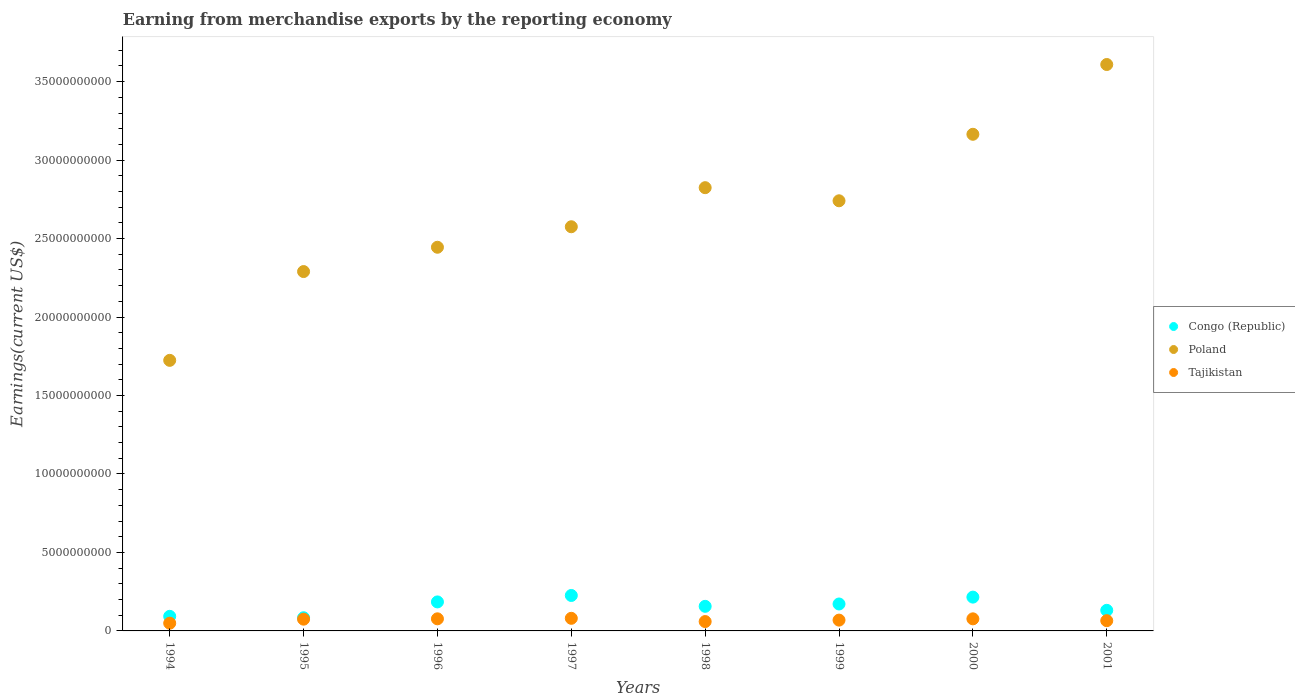Is the number of dotlines equal to the number of legend labels?
Your response must be concise. Yes. What is the amount earned from merchandise exports in Congo (Republic) in 1999?
Provide a short and direct response. 1.72e+09. Across all years, what is the maximum amount earned from merchandise exports in Congo (Republic)?
Offer a very short reply. 2.26e+09. Across all years, what is the minimum amount earned from merchandise exports in Tajikistan?
Give a very brief answer. 4.92e+08. In which year was the amount earned from merchandise exports in Tajikistan maximum?
Ensure brevity in your answer.  1997. What is the total amount earned from merchandise exports in Tajikistan in the graph?
Give a very brief answer. 5.52e+09. What is the difference between the amount earned from merchandise exports in Congo (Republic) in 1994 and that in 1998?
Your answer should be very brief. -6.38e+08. What is the difference between the amount earned from merchandise exports in Tajikistan in 1998 and the amount earned from merchandise exports in Congo (Republic) in 1999?
Offer a terse response. -1.12e+09. What is the average amount earned from merchandise exports in Poland per year?
Ensure brevity in your answer.  2.67e+1. In the year 1999, what is the difference between the amount earned from merchandise exports in Poland and amount earned from merchandise exports in Tajikistan?
Make the answer very short. 2.67e+1. What is the ratio of the amount earned from merchandise exports in Congo (Republic) in 1996 to that in 2000?
Ensure brevity in your answer.  0.86. Is the amount earned from merchandise exports in Tajikistan in 1996 less than that in 2001?
Ensure brevity in your answer.  No. What is the difference between the highest and the second highest amount earned from merchandise exports in Congo (Republic)?
Provide a short and direct response. 1.05e+08. What is the difference between the highest and the lowest amount earned from merchandise exports in Poland?
Give a very brief answer. 1.89e+1. In how many years, is the amount earned from merchandise exports in Poland greater than the average amount earned from merchandise exports in Poland taken over all years?
Your response must be concise. 4. Is the amount earned from merchandise exports in Poland strictly greater than the amount earned from merchandise exports in Congo (Republic) over the years?
Your response must be concise. Yes. How many years are there in the graph?
Offer a terse response. 8. Are the values on the major ticks of Y-axis written in scientific E-notation?
Make the answer very short. No. Does the graph contain any zero values?
Provide a succinct answer. No. Does the graph contain grids?
Give a very brief answer. No. How many legend labels are there?
Your answer should be compact. 3. How are the legend labels stacked?
Give a very brief answer. Vertical. What is the title of the graph?
Your answer should be compact. Earning from merchandise exports by the reporting economy. What is the label or title of the Y-axis?
Your answer should be compact. Earnings(current US$). What is the Earnings(current US$) of Congo (Republic) in 1994?
Ensure brevity in your answer.  9.29e+08. What is the Earnings(current US$) of Poland in 1994?
Your answer should be compact. 1.72e+1. What is the Earnings(current US$) in Tajikistan in 1994?
Give a very brief answer. 4.92e+08. What is the Earnings(current US$) of Congo (Republic) in 1995?
Your answer should be compact. 8.39e+08. What is the Earnings(current US$) of Poland in 1995?
Provide a succinct answer. 2.29e+1. What is the Earnings(current US$) in Tajikistan in 1995?
Provide a short and direct response. 7.49e+08. What is the Earnings(current US$) of Congo (Republic) in 1996?
Ensure brevity in your answer.  1.85e+09. What is the Earnings(current US$) of Poland in 1996?
Ensure brevity in your answer.  2.44e+1. What is the Earnings(current US$) in Tajikistan in 1996?
Your answer should be compact. 7.72e+08. What is the Earnings(current US$) of Congo (Republic) in 1997?
Your answer should be compact. 2.26e+09. What is the Earnings(current US$) in Poland in 1997?
Offer a very short reply. 2.58e+1. What is the Earnings(current US$) in Tajikistan in 1997?
Keep it short and to the point. 8.03e+08. What is the Earnings(current US$) in Congo (Republic) in 1998?
Give a very brief answer. 1.57e+09. What is the Earnings(current US$) in Poland in 1998?
Provide a succinct answer. 2.82e+1. What is the Earnings(current US$) of Tajikistan in 1998?
Provide a short and direct response. 5.97e+08. What is the Earnings(current US$) in Congo (Republic) in 1999?
Provide a short and direct response. 1.72e+09. What is the Earnings(current US$) in Poland in 1999?
Offer a terse response. 2.74e+1. What is the Earnings(current US$) of Tajikistan in 1999?
Offer a terse response. 6.89e+08. What is the Earnings(current US$) in Congo (Republic) in 2000?
Ensure brevity in your answer.  2.15e+09. What is the Earnings(current US$) in Poland in 2000?
Ensure brevity in your answer.  3.16e+1. What is the Earnings(current US$) of Tajikistan in 2000?
Your response must be concise. 7.70e+08. What is the Earnings(current US$) of Congo (Republic) in 2001?
Keep it short and to the point. 1.31e+09. What is the Earnings(current US$) in Poland in 2001?
Provide a succinct answer. 3.61e+1. What is the Earnings(current US$) of Tajikistan in 2001?
Ensure brevity in your answer.  6.53e+08. Across all years, what is the maximum Earnings(current US$) of Congo (Republic)?
Ensure brevity in your answer.  2.26e+09. Across all years, what is the maximum Earnings(current US$) in Poland?
Your response must be concise. 3.61e+1. Across all years, what is the maximum Earnings(current US$) of Tajikistan?
Provide a succinct answer. 8.03e+08. Across all years, what is the minimum Earnings(current US$) of Congo (Republic)?
Offer a very short reply. 8.39e+08. Across all years, what is the minimum Earnings(current US$) in Poland?
Your answer should be compact. 1.72e+1. Across all years, what is the minimum Earnings(current US$) of Tajikistan?
Your answer should be compact. 4.92e+08. What is the total Earnings(current US$) of Congo (Republic) in the graph?
Offer a very short reply. 1.26e+1. What is the total Earnings(current US$) of Poland in the graph?
Your response must be concise. 2.14e+11. What is the total Earnings(current US$) of Tajikistan in the graph?
Provide a short and direct response. 5.52e+09. What is the difference between the Earnings(current US$) of Congo (Republic) in 1994 and that in 1995?
Make the answer very short. 9.07e+07. What is the difference between the Earnings(current US$) of Poland in 1994 and that in 1995?
Offer a terse response. -5.66e+09. What is the difference between the Earnings(current US$) in Tajikistan in 1994 and that in 1995?
Your answer should be very brief. -2.57e+08. What is the difference between the Earnings(current US$) in Congo (Republic) in 1994 and that in 1996?
Give a very brief answer. -9.19e+08. What is the difference between the Earnings(current US$) of Poland in 1994 and that in 1996?
Provide a succinct answer. -7.21e+09. What is the difference between the Earnings(current US$) in Tajikistan in 1994 and that in 1996?
Your answer should be compact. -2.80e+08. What is the difference between the Earnings(current US$) of Congo (Republic) in 1994 and that in 1997?
Your answer should be very brief. -1.33e+09. What is the difference between the Earnings(current US$) in Poland in 1994 and that in 1997?
Your answer should be compact. -8.51e+09. What is the difference between the Earnings(current US$) of Tajikistan in 1994 and that in 1997?
Keep it short and to the point. -3.11e+08. What is the difference between the Earnings(current US$) in Congo (Republic) in 1994 and that in 1998?
Keep it short and to the point. -6.38e+08. What is the difference between the Earnings(current US$) of Poland in 1994 and that in 1998?
Give a very brief answer. -1.10e+1. What is the difference between the Earnings(current US$) of Tajikistan in 1994 and that in 1998?
Your response must be concise. -1.05e+08. What is the difference between the Earnings(current US$) in Congo (Republic) in 1994 and that in 1999?
Provide a succinct answer. -7.87e+08. What is the difference between the Earnings(current US$) in Poland in 1994 and that in 1999?
Ensure brevity in your answer.  -1.02e+1. What is the difference between the Earnings(current US$) in Tajikistan in 1994 and that in 1999?
Keep it short and to the point. -1.97e+08. What is the difference between the Earnings(current US$) in Congo (Republic) in 1994 and that in 2000?
Provide a short and direct response. -1.22e+09. What is the difference between the Earnings(current US$) in Poland in 1994 and that in 2000?
Offer a very short reply. -1.44e+1. What is the difference between the Earnings(current US$) in Tajikistan in 1994 and that in 2000?
Your answer should be very brief. -2.78e+08. What is the difference between the Earnings(current US$) in Congo (Republic) in 1994 and that in 2001?
Provide a short and direct response. -3.83e+08. What is the difference between the Earnings(current US$) in Poland in 1994 and that in 2001?
Provide a succinct answer. -1.89e+1. What is the difference between the Earnings(current US$) of Tajikistan in 1994 and that in 2001?
Make the answer very short. -1.61e+08. What is the difference between the Earnings(current US$) in Congo (Republic) in 1995 and that in 1996?
Ensure brevity in your answer.  -1.01e+09. What is the difference between the Earnings(current US$) of Poland in 1995 and that in 1996?
Keep it short and to the point. -1.55e+09. What is the difference between the Earnings(current US$) of Tajikistan in 1995 and that in 1996?
Keep it short and to the point. -2.29e+07. What is the difference between the Earnings(current US$) of Congo (Republic) in 1995 and that in 1997?
Keep it short and to the point. -1.42e+09. What is the difference between the Earnings(current US$) of Poland in 1995 and that in 1997?
Offer a very short reply. -2.86e+09. What is the difference between the Earnings(current US$) in Tajikistan in 1995 and that in 1997?
Give a very brief answer. -5.48e+07. What is the difference between the Earnings(current US$) of Congo (Republic) in 1995 and that in 1998?
Ensure brevity in your answer.  -7.28e+08. What is the difference between the Earnings(current US$) of Poland in 1995 and that in 1998?
Ensure brevity in your answer.  -5.35e+09. What is the difference between the Earnings(current US$) of Tajikistan in 1995 and that in 1998?
Make the answer very short. 1.52e+08. What is the difference between the Earnings(current US$) of Congo (Republic) in 1995 and that in 1999?
Ensure brevity in your answer.  -8.78e+08. What is the difference between the Earnings(current US$) of Poland in 1995 and that in 1999?
Provide a succinct answer. -4.51e+09. What is the difference between the Earnings(current US$) of Tajikistan in 1995 and that in 1999?
Give a very brief answer. 5.99e+07. What is the difference between the Earnings(current US$) in Congo (Republic) in 1995 and that in 2000?
Make the answer very short. -1.32e+09. What is the difference between the Earnings(current US$) of Poland in 1995 and that in 2000?
Your answer should be very brief. -8.75e+09. What is the difference between the Earnings(current US$) in Tajikistan in 1995 and that in 2000?
Ensure brevity in your answer.  -2.14e+07. What is the difference between the Earnings(current US$) in Congo (Republic) in 1995 and that in 2001?
Ensure brevity in your answer.  -4.73e+08. What is the difference between the Earnings(current US$) of Poland in 1995 and that in 2001?
Your response must be concise. -1.32e+1. What is the difference between the Earnings(current US$) of Tajikistan in 1995 and that in 2001?
Ensure brevity in your answer.  9.57e+07. What is the difference between the Earnings(current US$) in Congo (Republic) in 1996 and that in 1997?
Make the answer very short. -4.11e+08. What is the difference between the Earnings(current US$) of Poland in 1996 and that in 1997?
Keep it short and to the point. -1.31e+09. What is the difference between the Earnings(current US$) in Tajikistan in 1996 and that in 1997?
Give a very brief answer. -3.18e+07. What is the difference between the Earnings(current US$) of Congo (Republic) in 1996 and that in 1998?
Give a very brief answer. 2.81e+08. What is the difference between the Earnings(current US$) of Poland in 1996 and that in 1998?
Make the answer very short. -3.80e+09. What is the difference between the Earnings(current US$) in Tajikistan in 1996 and that in 1998?
Make the answer very short. 1.75e+08. What is the difference between the Earnings(current US$) in Congo (Republic) in 1996 and that in 1999?
Your answer should be compact. 1.32e+08. What is the difference between the Earnings(current US$) in Poland in 1996 and that in 1999?
Provide a short and direct response. -2.96e+09. What is the difference between the Earnings(current US$) in Tajikistan in 1996 and that in 1999?
Your answer should be compact. 8.29e+07. What is the difference between the Earnings(current US$) of Congo (Republic) in 1996 and that in 2000?
Your response must be concise. -3.06e+08. What is the difference between the Earnings(current US$) of Poland in 1996 and that in 2000?
Make the answer very short. -7.20e+09. What is the difference between the Earnings(current US$) in Tajikistan in 1996 and that in 2000?
Provide a short and direct response. 1.53e+06. What is the difference between the Earnings(current US$) of Congo (Republic) in 1996 and that in 2001?
Offer a very short reply. 5.36e+08. What is the difference between the Earnings(current US$) in Poland in 1996 and that in 2001?
Provide a short and direct response. -1.16e+1. What is the difference between the Earnings(current US$) in Tajikistan in 1996 and that in 2001?
Your answer should be very brief. 1.19e+08. What is the difference between the Earnings(current US$) in Congo (Republic) in 1997 and that in 1998?
Provide a succinct answer. 6.92e+08. What is the difference between the Earnings(current US$) in Poland in 1997 and that in 1998?
Make the answer very short. -2.49e+09. What is the difference between the Earnings(current US$) in Tajikistan in 1997 and that in 1998?
Keep it short and to the point. 2.07e+08. What is the difference between the Earnings(current US$) of Congo (Republic) in 1997 and that in 1999?
Make the answer very short. 5.42e+08. What is the difference between the Earnings(current US$) of Poland in 1997 and that in 1999?
Offer a very short reply. -1.65e+09. What is the difference between the Earnings(current US$) of Tajikistan in 1997 and that in 1999?
Provide a short and direct response. 1.15e+08. What is the difference between the Earnings(current US$) in Congo (Republic) in 1997 and that in 2000?
Provide a succinct answer. 1.05e+08. What is the difference between the Earnings(current US$) in Poland in 1997 and that in 2000?
Ensure brevity in your answer.  -5.89e+09. What is the difference between the Earnings(current US$) of Tajikistan in 1997 and that in 2000?
Offer a very short reply. 3.34e+07. What is the difference between the Earnings(current US$) of Congo (Republic) in 1997 and that in 2001?
Offer a terse response. 9.47e+08. What is the difference between the Earnings(current US$) in Poland in 1997 and that in 2001?
Provide a short and direct response. -1.03e+1. What is the difference between the Earnings(current US$) in Tajikistan in 1997 and that in 2001?
Provide a succinct answer. 1.50e+08. What is the difference between the Earnings(current US$) in Congo (Republic) in 1998 and that in 1999?
Provide a short and direct response. -1.49e+08. What is the difference between the Earnings(current US$) of Poland in 1998 and that in 1999?
Make the answer very short. 8.36e+08. What is the difference between the Earnings(current US$) of Tajikistan in 1998 and that in 1999?
Offer a terse response. -9.21e+07. What is the difference between the Earnings(current US$) in Congo (Republic) in 1998 and that in 2000?
Ensure brevity in your answer.  -5.87e+08. What is the difference between the Earnings(current US$) of Poland in 1998 and that in 2000?
Keep it short and to the point. -3.40e+09. What is the difference between the Earnings(current US$) in Tajikistan in 1998 and that in 2000?
Your response must be concise. -1.73e+08. What is the difference between the Earnings(current US$) of Congo (Republic) in 1998 and that in 2001?
Your answer should be very brief. 2.55e+08. What is the difference between the Earnings(current US$) of Poland in 1998 and that in 2001?
Keep it short and to the point. -7.85e+09. What is the difference between the Earnings(current US$) of Tajikistan in 1998 and that in 2001?
Make the answer very short. -5.63e+07. What is the difference between the Earnings(current US$) of Congo (Republic) in 1999 and that in 2000?
Your response must be concise. -4.38e+08. What is the difference between the Earnings(current US$) in Poland in 1999 and that in 2000?
Your answer should be very brief. -4.24e+09. What is the difference between the Earnings(current US$) of Tajikistan in 1999 and that in 2000?
Make the answer very short. -8.13e+07. What is the difference between the Earnings(current US$) of Congo (Republic) in 1999 and that in 2001?
Provide a short and direct response. 4.04e+08. What is the difference between the Earnings(current US$) of Poland in 1999 and that in 2001?
Offer a very short reply. -8.68e+09. What is the difference between the Earnings(current US$) in Tajikistan in 1999 and that in 2001?
Ensure brevity in your answer.  3.58e+07. What is the difference between the Earnings(current US$) in Congo (Republic) in 2000 and that in 2001?
Offer a very short reply. 8.42e+08. What is the difference between the Earnings(current US$) in Poland in 2000 and that in 2001?
Give a very brief answer. -4.45e+09. What is the difference between the Earnings(current US$) in Tajikistan in 2000 and that in 2001?
Offer a terse response. 1.17e+08. What is the difference between the Earnings(current US$) in Congo (Republic) in 1994 and the Earnings(current US$) in Poland in 1995?
Your answer should be very brief. -2.20e+1. What is the difference between the Earnings(current US$) of Congo (Republic) in 1994 and the Earnings(current US$) of Tajikistan in 1995?
Give a very brief answer. 1.81e+08. What is the difference between the Earnings(current US$) of Poland in 1994 and the Earnings(current US$) of Tajikistan in 1995?
Provide a short and direct response. 1.65e+1. What is the difference between the Earnings(current US$) in Congo (Republic) in 1994 and the Earnings(current US$) in Poland in 1996?
Your answer should be compact. -2.35e+1. What is the difference between the Earnings(current US$) of Congo (Republic) in 1994 and the Earnings(current US$) of Tajikistan in 1996?
Your response must be concise. 1.58e+08. What is the difference between the Earnings(current US$) of Poland in 1994 and the Earnings(current US$) of Tajikistan in 1996?
Provide a succinct answer. 1.65e+1. What is the difference between the Earnings(current US$) in Congo (Republic) in 1994 and the Earnings(current US$) in Poland in 1997?
Ensure brevity in your answer.  -2.48e+1. What is the difference between the Earnings(current US$) of Congo (Republic) in 1994 and the Earnings(current US$) of Tajikistan in 1997?
Ensure brevity in your answer.  1.26e+08. What is the difference between the Earnings(current US$) of Poland in 1994 and the Earnings(current US$) of Tajikistan in 1997?
Offer a very short reply. 1.64e+1. What is the difference between the Earnings(current US$) of Congo (Republic) in 1994 and the Earnings(current US$) of Poland in 1998?
Your response must be concise. -2.73e+1. What is the difference between the Earnings(current US$) of Congo (Republic) in 1994 and the Earnings(current US$) of Tajikistan in 1998?
Provide a succinct answer. 3.33e+08. What is the difference between the Earnings(current US$) of Poland in 1994 and the Earnings(current US$) of Tajikistan in 1998?
Make the answer very short. 1.66e+1. What is the difference between the Earnings(current US$) of Congo (Republic) in 1994 and the Earnings(current US$) of Poland in 1999?
Ensure brevity in your answer.  -2.65e+1. What is the difference between the Earnings(current US$) in Congo (Republic) in 1994 and the Earnings(current US$) in Tajikistan in 1999?
Your answer should be compact. 2.41e+08. What is the difference between the Earnings(current US$) of Poland in 1994 and the Earnings(current US$) of Tajikistan in 1999?
Offer a terse response. 1.66e+1. What is the difference between the Earnings(current US$) in Congo (Republic) in 1994 and the Earnings(current US$) in Poland in 2000?
Provide a short and direct response. -3.07e+1. What is the difference between the Earnings(current US$) in Congo (Republic) in 1994 and the Earnings(current US$) in Tajikistan in 2000?
Your answer should be compact. 1.59e+08. What is the difference between the Earnings(current US$) of Poland in 1994 and the Earnings(current US$) of Tajikistan in 2000?
Provide a succinct answer. 1.65e+1. What is the difference between the Earnings(current US$) of Congo (Republic) in 1994 and the Earnings(current US$) of Poland in 2001?
Your answer should be compact. -3.52e+1. What is the difference between the Earnings(current US$) of Congo (Republic) in 1994 and the Earnings(current US$) of Tajikistan in 2001?
Provide a succinct answer. 2.76e+08. What is the difference between the Earnings(current US$) of Poland in 1994 and the Earnings(current US$) of Tajikistan in 2001?
Offer a very short reply. 1.66e+1. What is the difference between the Earnings(current US$) in Congo (Republic) in 1995 and the Earnings(current US$) in Poland in 1996?
Your answer should be compact. -2.36e+1. What is the difference between the Earnings(current US$) of Congo (Republic) in 1995 and the Earnings(current US$) of Tajikistan in 1996?
Offer a terse response. 6.71e+07. What is the difference between the Earnings(current US$) in Poland in 1995 and the Earnings(current US$) in Tajikistan in 1996?
Offer a terse response. 2.21e+1. What is the difference between the Earnings(current US$) of Congo (Republic) in 1995 and the Earnings(current US$) of Poland in 1997?
Keep it short and to the point. -2.49e+1. What is the difference between the Earnings(current US$) in Congo (Republic) in 1995 and the Earnings(current US$) in Tajikistan in 1997?
Make the answer very short. 3.53e+07. What is the difference between the Earnings(current US$) of Poland in 1995 and the Earnings(current US$) of Tajikistan in 1997?
Offer a very short reply. 2.21e+1. What is the difference between the Earnings(current US$) in Congo (Republic) in 1995 and the Earnings(current US$) in Poland in 1998?
Provide a short and direct response. -2.74e+1. What is the difference between the Earnings(current US$) of Congo (Republic) in 1995 and the Earnings(current US$) of Tajikistan in 1998?
Keep it short and to the point. 2.42e+08. What is the difference between the Earnings(current US$) of Poland in 1995 and the Earnings(current US$) of Tajikistan in 1998?
Provide a short and direct response. 2.23e+1. What is the difference between the Earnings(current US$) of Congo (Republic) in 1995 and the Earnings(current US$) of Poland in 1999?
Provide a succinct answer. -2.66e+1. What is the difference between the Earnings(current US$) in Congo (Republic) in 1995 and the Earnings(current US$) in Tajikistan in 1999?
Keep it short and to the point. 1.50e+08. What is the difference between the Earnings(current US$) in Poland in 1995 and the Earnings(current US$) in Tajikistan in 1999?
Give a very brief answer. 2.22e+1. What is the difference between the Earnings(current US$) of Congo (Republic) in 1995 and the Earnings(current US$) of Poland in 2000?
Provide a succinct answer. -3.08e+1. What is the difference between the Earnings(current US$) of Congo (Republic) in 1995 and the Earnings(current US$) of Tajikistan in 2000?
Your response must be concise. 6.86e+07. What is the difference between the Earnings(current US$) in Poland in 1995 and the Earnings(current US$) in Tajikistan in 2000?
Provide a succinct answer. 2.21e+1. What is the difference between the Earnings(current US$) in Congo (Republic) in 1995 and the Earnings(current US$) in Poland in 2001?
Your answer should be compact. -3.53e+1. What is the difference between the Earnings(current US$) in Congo (Republic) in 1995 and the Earnings(current US$) in Tajikistan in 2001?
Make the answer very short. 1.86e+08. What is the difference between the Earnings(current US$) in Poland in 1995 and the Earnings(current US$) in Tajikistan in 2001?
Ensure brevity in your answer.  2.22e+1. What is the difference between the Earnings(current US$) in Congo (Republic) in 1996 and the Earnings(current US$) in Poland in 1997?
Make the answer very short. -2.39e+1. What is the difference between the Earnings(current US$) in Congo (Republic) in 1996 and the Earnings(current US$) in Tajikistan in 1997?
Provide a short and direct response. 1.04e+09. What is the difference between the Earnings(current US$) of Poland in 1996 and the Earnings(current US$) of Tajikistan in 1997?
Ensure brevity in your answer.  2.36e+1. What is the difference between the Earnings(current US$) in Congo (Republic) in 1996 and the Earnings(current US$) in Poland in 1998?
Ensure brevity in your answer.  -2.64e+1. What is the difference between the Earnings(current US$) in Congo (Republic) in 1996 and the Earnings(current US$) in Tajikistan in 1998?
Your answer should be very brief. 1.25e+09. What is the difference between the Earnings(current US$) in Poland in 1996 and the Earnings(current US$) in Tajikistan in 1998?
Offer a very short reply. 2.39e+1. What is the difference between the Earnings(current US$) of Congo (Republic) in 1996 and the Earnings(current US$) of Poland in 1999?
Provide a succinct answer. -2.56e+1. What is the difference between the Earnings(current US$) of Congo (Republic) in 1996 and the Earnings(current US$) of Tajikistan in 1999?
Your answer should be very brief. 1.16e+09. What is the difference between the Earnings(current US$) in Poland in 1996 and the Earnings(current US$) in Tajikistan in 1999?
Keep it short and to the point. 2.38e+1. What is the difference between the Earnings(current US$) in Congo (Republic) in 1996 and the Earnings(current US$) in Poland in 2000?
Give a very brief answer. -2.98e+1. What is the difference between the Earnings(current US$) in Congo (Republic) in 1996 and the Earnings(current US$) in Tajikistan in 2000?
Keep it short and to the point. 1.08e+09. What is the difference between the Earnings(current US$) of Poland in 1996 and the Earnings(current US$) of Tajikistan in 2000?
Your answer should be very brief. 2.37e+1. What is the difference between the Earnings(current US$) in Congo (Republic) in 1996 and the Earnings(current US$) in Poland in 2001?
Your answer should be very brief. -3.42e+1. What is the difference between the Earnings(current US$) in Congo (Republic) in 1996 and the Earnings(current US$) in Tajikistan in 2001?
Provide a succinct answer. 1.20e+09. What is the difference between the Earnings(current US$) in Poland in 1996 and the Earnings(current US$) in Tajikistan in 2001?
Offer a very short reply. 2.38e+1. What is the difference between the Earnings(current US$) of Congo (Republic) in 1997 and the Earnings(current US$) of Poland in 1998?
Provide a succinct answer. -2.60e+1. What is the difference between the Earnings(current US$) of Congo (Republic) in 1997 and the Earnings(current US$) of Tajikistan in 1998?
Your answer should be very brief. 1.66e+09. What is the difference between the Earnings(current US$) in Poland in 1997 and the Earnings(current US$) in Tajikistan in 1998?
Keep it short and to the point. 2.52e+1. What is the difference between the Earnings(current US$) of Congo (Republic) in 1997 and the Earnings(current US$) of Poland in 1999?
Your response must be concise. -2.51e+1. What is the difference between the Earnings(current US$) in Congo (Republic) in 1997 and the Earnings(current US$) in Tajikistan in 1999?
Make the answer very short. 1.57e+09. What is the difference between the Earnings(current US$) in Poland in 1997 and the Earnings(current US$) in Tajikistan in 1999?
Your answer should be compact. 2.51e+1. What is the difference between the Earnings(current US$) in Congo (Republic) in 1997 and the Earnings(current US$) in Poland in 2000?
Offer a terse response. -2.94e+1. What is the difference between the Earnings(current US$) of Congo (Republic) in 1997 and the Earnings(current US$) of Tajikistan in 2000?
Keep it short and to the point. 1.49e+09. What is the difference between the Earnings(current US$) in Poland in 1997 and the Earnings(current US$) in Tajikistan in 2000?
Your response must be concise. 2.50e+1. What is the difference between the Earnings(current US$) of Congo (Republic) in 1997 and the Earnings(current US$) of Poland in 2001?
Your response must be concise. -3.38e+1. What is the difference between the Earnings(current US$) of Congo (Republic) in 1997 and the Earnings(current US$) of Tajikistan in 2001?
Give a very brief answer. 1.61e+09. What is the difference between the Earnings(current US$) in Poland in 1997 and the Earnings(current US$) in Tajikistan in 2001?
Keep it short and to the point. 2.51e+1. What is the difference between the Earnings(current US$) of Congo (Republic) in 1998 and the Earnings(current US$) of Poland in 1999?
Provide a succinct answer. -2.58e+1. What is the difference between the Earnings(current US$) of Congo (Republic) in 1998 and the Earnings(current US$) of Tajikistan in 1999?
Offer a terse response. 8.78e+08. What is the difference between the Earnings(current US$) of Poland in 1998 and the Earnings(current US$) of Tajikistan in 1999?
Your answer should be very brief. 2.76e+1. What is the difference between the Earnings(current US$) of Congo (Republic) in 1998 and the Earnings(current US$) of Poland in 2000?
Your answer should be very brief. -3.01e+1. What is the difference between the Earnings(current US$) in Congo (Republic) in 1998 and the Earnings(current US$) in Tajikistan in 2000?
Your answer should be very brief. 7.97e+08. What is the difference between the Earnings(current US$) of Poland in 1998 and the Earnings(current US$) of Tajikistan in 2000?
Ensure brevity in your answer.  2.75e+1. What is the difference between the Earnings(current US$) of Congo (Republic) in 1998 and the Earnings(current US$) of Poland in 2001?
Your response must be concise. -3.45e+1. What is the difference between the Earnings(current US$) of Congo (Republic) in 1998 and the Earnings(current US$) of Tajikistan in 2001?
Offer a very short reply. 9.14e+08. What is the difference between the Earnings(current US$) of Poland in 1998 and the Earnings(current US$) of Tajikistan in 2001?
Give a very brief answer. 2.76e+1. What is the difference between the Earnings(current US$) in Congo (Republic) in 1999 and the Earnings(current US$) in Poland in 2000?
Your answer should be very brief. -2.99e+1. What is the difference between the Earnings(current US$) in Congo (Republic) in 1999 and the Earnings(current US$) in Tajikistan in 2000?
Provide a short and direct response. 9.46e+08. What is the difference between the Earnings(current US$) of Poland in 1999 and the Earnings(current US$) of Tajikistan in 2000?
Keep it short and to the point. 2.66e+1. What is the difference between the Earnings(current US$) in Congo (Republic) in 1999 and the Earnings(current US$) in Poland in 2001?
Provide a succinct answer. -3.44e+1. What is the difference between the Earnings(current US$) of Congo (Republic) in 1999 and the Earnings(current US$) of Tajikistan in 2001?
Ensure brevity in your answer.  1.06e+09. What is the difference between the Earnings(current US$) in Poland in 1999 and the Earnings(current US$) in Tajikistan in 2001?
Give a very brief answer. 2.68e+1. What is the difference between the Earnings(current US$) in Congo (Republic) in 2000 and the Earnings(current US$) in Poland in 2001?
Your answer should be very brief. -3.39e+1. What is the difference between the Earnings(current US$) in Congo (Republic) in 2000 and the Earnings(current US$) in Tajikistan in 2001?
Keep it short and to the point. 1.50e+09. What is the difference between the Earnings(current US$) in Poland in 2000 and the Earnings(current US$) in Tajikistan in 2001?
Ensure brevity in your answer.  3.10e+1. What is the average Earnings(current US$) of Congo (Republic) per year?
Your answer should be compact. 1.58e+09. What is the average Earnings(current US$) of Poland per year?
Give a very brief answer. 2.67e+1. What is the average Earnings(current US$) of Tajikistan per year?
Offer a terse response. 6.90e+08. In the year 1994, what is the difference between the Earnings(current US$) in Congo (Republic) and Earnings(current US$) in Poland?
Your answer should be very brief. -1.63e+1. In the year 1994, what is the difference between the Earnings(current US$) of Congo (Republic) and Earnings(current US$) of Tajikistan?
Give a very brief answer. 4.37e+08. In the year 1994, what is the difference between the Earnings(current US$) of Poland and Earnings(current US$) of Tajikistan?
Your answer should be compact. 1.67e+1. In the year 1995, what is the difference between the Earnings(current US$) of Congo (Republic) and Earnings(current US$) of Poland?
Your answer should be compact. -2.21e+1. In the year 1995, what is the difference between the Earnings(current US$) in Congo (Republic) and Earnings(current US$) in Tajikistan?
Offer a terse response. 9.00e+07. In the year 1995, what is the difference between the Earnings(current US$) in Poland and Earnings(current US$) in Tajikistan?
Your answer should be compact. 2.22e+1. In the year 1996, what is the difference between the Earnings(current US$) of Congo (Republic) and Earnings(current US$) of Poland?
Provide a short and direct response. -2.26e+1. In the year 1996, what is the difference between the Earnings(current US$) in Congo (Republic) and Earnings(current US$) in Tajikistan?
Offer a terse response. 1.08e+09. In the year 1996, what is the difference between the Earnings(current US$) of Poland and Earnings(current US$) of Tajikistan?
Provide a succinct answer. 2.37e+1. In the year 1997, what is the difference between the Earnings(current US$) of Congo (Republic) and Earnings(current US$) of Poland?
Give a very brief answer. -2.35e+1. In the year 1997, what is the difference between the Earnings(current US$) of Congo (Republic) and Earnings(current US$) of Tajikistan?
Keep it short and to the point. 1.46e+09. In the year 1997, what is the difference between the Earnings(current US$) of Poland and Earnings(current US$) of Tajikistan?
Ensure brevity in your answer.  2.50e+1. In the year 1998, what is the difference between the Earnings(current US$) of Congo (Republic) and Earnings(current US$) of Poland?
Your answer should be compact. -2.67e+1. In the year 1998, what is the difference between the Earnings(current US$) in Congo (Republic) and Earnings(current US$) in Tajikistan?
Your answer should be compact. 9.70e+08. In the year 1998, what is the difference between the Earnings(current US$) in Poland and Earnings(current US$) in Tajikistan?
Your response must be concise. 2.76e+1. In the year 1999, what is the difference between the Earnings(current US$) in Congo (Republic) and Earnings(current US$) in Poland?
Ensure brevity in your answer.  -2.57e+1. In the year 1999, what is the difference between the Earnings(current US$) in Congo (Republic) and Earnings(current US$) in Tajikistan?
Keep it short and to the point. 1.03e+09. In the year 1999, what is the difference between the Earnings(current US$) in Poland and Earnings(current US$) in Tajikistan?
Your answer should be compact. 2.67e+1. In the year 2000, what is the difference between the Earnings(current US$) in Congo (Republic) and Earnings(current US$) in Poland?
Provide a short and direct response. -2.95e+1. In the year 2000, what is the difference between the Earnings(current US$) in Congo (Republic) and Earnings(current US$) in Tajikistan?
Provide a short and direct response. 1.38e+09. In the year 2000, what is the difference between the Earnings(current US$) of Poland and Earnings(current US$) of Tajikistan?
Provide a short and direct response. 3.09e+1. In the year 2001, what is the difference between the Earnings(current US$) of Congo (Republic) and Earnings(current US$) of Poland?
Provide a succinct answer. -3.48e+1. In the year 2001, what is the difference between the Earnings(current US$) in Congo (Republic) and Earnings(current US$) in Tajikistan?
Provide a succinct answer. 6.59e+08. In the year 2001, what is the difference between the Earnings(current US$) of Poland and Earnings(current US$) of Tajikistan?
Offer a very short reply. 3.54e+1. What is the ratio of the Earnings(current US$) of Congo (Republic) in 1994 to that in 1995?
Make the answer very short. 1.11. What is the ratio of the Earnings(current US$) in Poland in 1994 to that in 1995?
Make the answer very short. 0.75. What is the ratio of the Earnings(current US$) of Tajikistan in 1994 to that in 1995?
Your response must be concise. 0.66. What is the ratio of the Earnings(current US$) of Congo (Republic) in 1994 to that in 1996?
Offer a very short reply. 0.5. What is the ratio of the Earnings(current US$) of Poland in 1994 to that in 1996?
Offer a terse response. 0.71. What is the ratio of the Earnings(current US$) of Tajikistan in 1994 to that in 1996?
Provide a succinct answer. 0.64. What is the ratio of the Earnings(current US$) in Congo (Republic) in 1994 to that in 1997?
Make the answer very short. 0.41. What is the ratio of the Earnings(current US$) of Poland in 1994 to that in 1997?
Give a very brief answer. 0.67. What is the ratio of the Earnings(current US$) of Tajikistan in 1994 to that in 1997?
Provide a short and direct response. 0.61. What is the ratio of the Earnings(current US$) of Congo (Republic) in 1994 to that in 1998?
Your answer should be very brief. 0.59. What is the ratio of the Earnings(current US$) of Poland in 1994 to that in 1998?
Your response must be concise. 0.61. What is the ratio of the Earnings(current US$) in Tajikistan in 1994 to that in 1998?
Your answer should be very brief. 0.82. What is the ratio of the Earnings(current US$) in Congo (Republic) in 1994 to that in 1999?
Make the answer very short. 0.54. What is the ratio of the Earnings(current US$) of Poland in 1994 to that in 1999?
Your answer should be very brief. 0.63. What is the ratio of the Earnings(current US$) in Congo (Republic) in 1994 to that in 2000?
Your answer should be compact. 0.43. What is the ratio of the Earnings(current US$) of Poland in 1994 to that in 2000?
Give a very brief answer. 0.54. What is the ratio of the Earnings(current US$) in Tajikistan in 1994 to that in 2000?
Keep it short and to the point. 0.64. What is the ratio of the Earnings(current US$) in Congo (Republic) in 1994 to that in 2001?
Make the answer very short. 0.71. What is the ratio of the Earnings(current US$) in Poland in 1994 to that in 2001?
Provide a succinct answer. 0.48. What is the ratio of the Earnings(current US$) in Tajikistan in 1994 to that in 2001?
Your answer should be compact. 0.75. What is the ratio of the Earnings(current US$) in Congo (Republic) in 1995 to that in 1996?
Make the answer very short. 0.45. What is the ratio of the Earnings(current US$) of Poland in 1995 to that in 1996?
Provide a succinct answer. 0.94. What is the ratio of the Earnings(current US$) in Tajikistan in 1995 to that in 1996?
Provide a short and direct response. 0.97. What is the ratio of the Earnings(current US$) of Congo (Republic) in 1995 to that in 1997?
Your answer should be very brief. 0.37. What is the ratio of the Earnings(current US$) of Poland in 1995 to that in 1997?
Provide a short and direct response. 0.89. What is the ratio of the Earnings(current US$) of Tajikistan in 1995 to that in 1997?
Provide a succinct answer. 0.93. What is the ratio of the Earnings(current US$) in Congo (Republic) in 1995 to that in 1998?
Make the answer very short. 0.54. What is the ratio of the Earnings(current US$) of Poland in 1995 to that in 1998?
Offer a very short reply. 0.81. What is the ratio of the Earnings(current US$) of Tajikistan in 1995 to that in 1998?
Keep it short and to the point. 1.25. What is the ratio of the Earnings(current US$) of Congo (Republic) in 1995 to that in 1999?
Provide a short and direct response. 0.49. What is the ratio of the Earnings(current US$) of Poland in 1995 to that in 1999?
Your response must be concise. 0.84. What is the ratio of the Earnings(current US$) in Tajikistan in 1995 to that in 1999?
Your response must be concise. 1.09. What is the ratio of the Earnings(current US$) of Congo (Republic) in 1995 to that in 2000?
Give a very brief answer. 0.39. What is the ratio of the Earnings(current US$) in Poland in 1995 to that in 2000?
Ensure brevity in your answer.  0.72. What is the ratio of the Earnings(current US$) in Tajikistan in 1995 to that in 2000?
Offer a terse response. 0.97. What is the ratio of the Earnings(current US$) in Congo (Republic) in 1995 to that in 2001?
Offer a terse response. 0.64. What is the ratio of the Earnings(current US$) of Poland in 1995 to that in 2001?
Offer a very short reply. 0.63. What is the ratio of the Earnings(current US$) in Tajikistan in 1995 to that in 2001?
Keep it short and to the point. 1.15. What is the ratio of the Earnings(current US$) in Congo (Republic) in 1996 to that in 1997?
Provide a short and direct response. 0.82. What is the ratio of the Earnings(current US$) in Poland in 1996 to that in 1997?
Your answer should be compact. 0.95. What is the ratio of the Earnings(current US$) in Tajikistan in 1996 to that in 1997?
Provide a short and direct response. 0.96. What is the ratio of the Earnings(current US$) of Congo (Republic) in 1996 to that in 1998?
Your answer should be compact. 1.18. What is the ratio of the Earnings(current US$) of Poland in 1996 to that in 1998?
Offer a terse response. 0.87. What is the ratio of the Earnings(current US$) of Tajikistan in 1996 to that in 1998?
Make the answer very short. 1.29. What is the ratio of the Earnings(current US$) in Congo (Republic) in 1996 to that in 1999?
Offer a very short reply. 1.08. What is the ratio of the Earnings(current US$) in Poland in 1996 to that in 1999?
Ensure brevity in your answer.  0.89. What is the ratio of the Earnings(current US$) in Tajikistan in 1996 to that in 1999?
Your response must be concise. 1.12. What is the ratio of the Earnings(current US$) of Congo (Republic) in 1996 to that in 2000?
Offer a terse response. 0.86. What is the ratio of the Earnings(current US$) in Poland in 1996 to that in 2000?
Your answer should be compact. 0.77. What is the ratio of the Earnings(current US$) in Congo (Republic) in 1996 to that in 2001?
Keep it short and to the point. 1.41. What is the ratio of the Earnings(current US$) of Poland in 1996 to that in 2001?
Ensure brevity in your answer.  0.68. What is the ratio of the Earnings(current US$) of Tajikistan in 1996 to that in 2001?
Provide a short and direct response. 1.18. What is the ratio of the Earnings(current US$) of Congo (Republic) in 1997 to that in 1998?
Your response must be concise. 1.44. What is the ratio of the Earnings(current US$) of Poland in 1997 to that in 1998?
Offer a very short reply. 0.91. What is the ratio of the Earnings(current US$) of Tajikistan in 1997 to that in 1998?
Your response must be concise. 1.35. What is the ratio of the Earnings(current US$) of Congo (Republic) in 1997 to that in 1999?
Your response must be concise. 1.32. What is the ratio of the Earnings(current US$) of Poland in 1997 to that in 1999?
Ensure brevity in your answer.  0.94. What is the ratio of the Earnings(current US$) in Tajikistan in 1997 to that in 1999?
Provide a short and direct response. 1.17. What is the ratio of the Earnings(current US$) in Congo (Republic) in 1997 to that in 2000?
Offer a terse response. 1.05. What is the ratio of the Earnings(current US$) of Poland in 1997 to that in 2000?
Your answer should be very brief. 0.81. What is the ratio of the Earnings(current US$) in Tajikistan in 1997 to that in 2000?
Offer a terse response. 1.04. What is the ratio of the Earnings(current US$) in Congo (Republic) in 1997 to that in 2001?
Your answer should be compact. 1.72. What is the ratio of the Earnings(current US$) in Poland in 1997 to that in 2001?
Your answer should be compact. 0.71. What is the ratio of the Earnings(current US$) of Tajikistan in 1997 to that in 2001?
Your answer should be very brief. 1.23. What is the ratio of the Earnings(current US$) of Poland in 1998 to that in 1999?
Offer a terse response. 1.03. What is the ratio of the Earnings(current US$) in Tajikistan in 1998 to that in 1999?
Keep it short and to the point. 0.87. What is the ratio of the Earnings(current US$) of Congo (Republic) in 1998 to that in 2000?
Give a very brief answer. 0.73. What is the ratio of the Earnings(current US$) of Poland in 1998 to that in 2000?
Make the answer very short. 0.89. What is the ratio of the Earnings(current US$) in Tajikistan in 1998 to that in 2000?
Offer a terse response. 0.77. What is the ratio of the Earnings(current US$) of Congo (Republic) in 1998 to that in 2001?
Your response must be concise. 1.19. What is the ratio of the Earnings(current US$) in Poland in 1998 to that in 2001?
Your answer should be compact. 0.78. What is the ratio of the Earnings(current US$) of Tajikistan in 1998 to that in 2001?
Your answer should be compact. 0.91. What is the ratio of the Earnings(current US$) of Congo (Republic) in 1999 to that in 2000?
Provide a short and direct response. 0.8. What is the ratio of the Earnings(current US$) of Poland in 1999 to that in 2000?
Provide a short and direct response. 0.87. What is the ratio of the Earnings(current US$) of Tajikistan in 1999 to that in 2000?
Ensure brevity in your answer.  0.89. What is the ratio of the Earnings(current US$) of Congo (Republic) in 1999 to that in 2001?
Your answer should be compact. 1.31. What is the ratio of the Earnings(current US$) in Poland in 1999 to that in 2001?
Make the answer very short. 0.76. What is the ratio of the Earnings(current US$) of Tajikistan in 1999 to that in 2001?
Make the answer very short. 1.05. What is the ratio of the Earnings(current US$) of Congo (Republic) in 2000 to that in 2001?
Provide a succinct answer. 1.64. What is the ratio of the Earnings(current US$) of Poland in 2000 to that in 2001?
Your answer should be very brief. 0.88. What is the ratio of the Earnings(current US$) of Tajikistan in 2000 to that in 2001?
Your response must be concise. 1.18. What is the difference between the highest and the second highest Earnings(current US$) in Congo (Republic)?
Make the answer very short. 1.05e+08. What is the difference between the highest and the second highest Earnings(current US$) in Poland?
Offer a terse response. 4.45e+09. What is the difference between the highest and the second highest Earnings(current US$) in Tajikistan?
Keep it short and to the point. 3.18e+07. What is the difference between the highest and the lowest Earnings(current US$) in Congo (Republic)?
Give a very brief answer. 1.42e+09. What is the difference between the highest and the lowest Earnings(current US$) in Poland?
Give a very brief answer. 1.89e+1. What is the difference between the highest and the lowest Earnings(current US$) of Tajikistan?
Your answer should be very brief. 3.11e+08. 